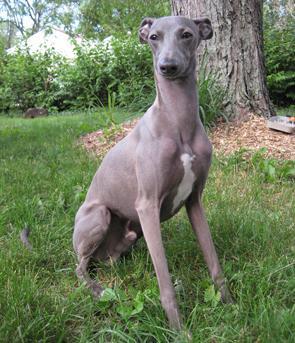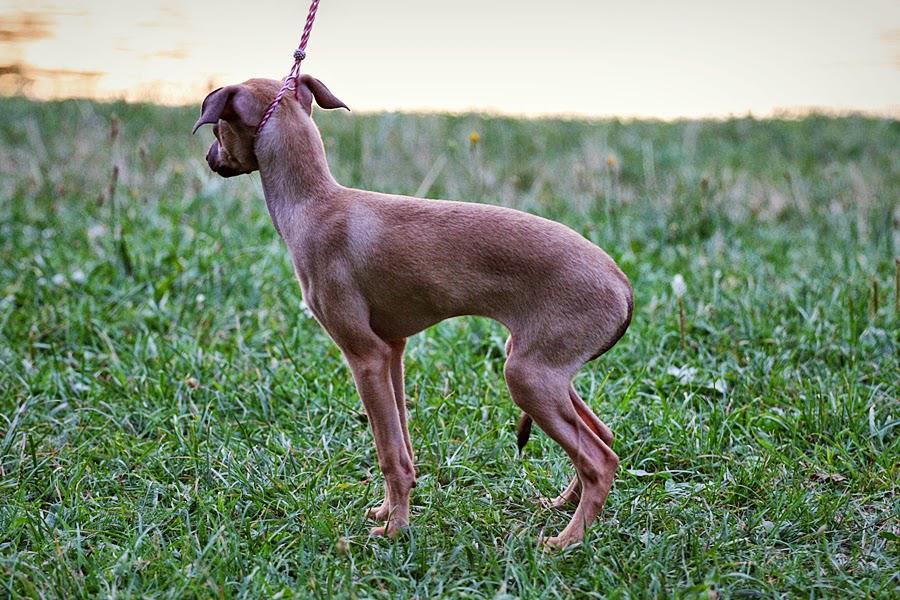The first image is the image on the left, the second image is the image on the right. Examine the images to the left and right. Is the description "A dog standing on all fours in the grass is posed in front of a wall of some type and looking toward the right." accurate? Answer yes or no. No. The first image is the image on the left, the second image is the image on the right. Considering the images on both sides, is "The dog in one of the images is standing near a fence." valid? Answer yes or no. No. 